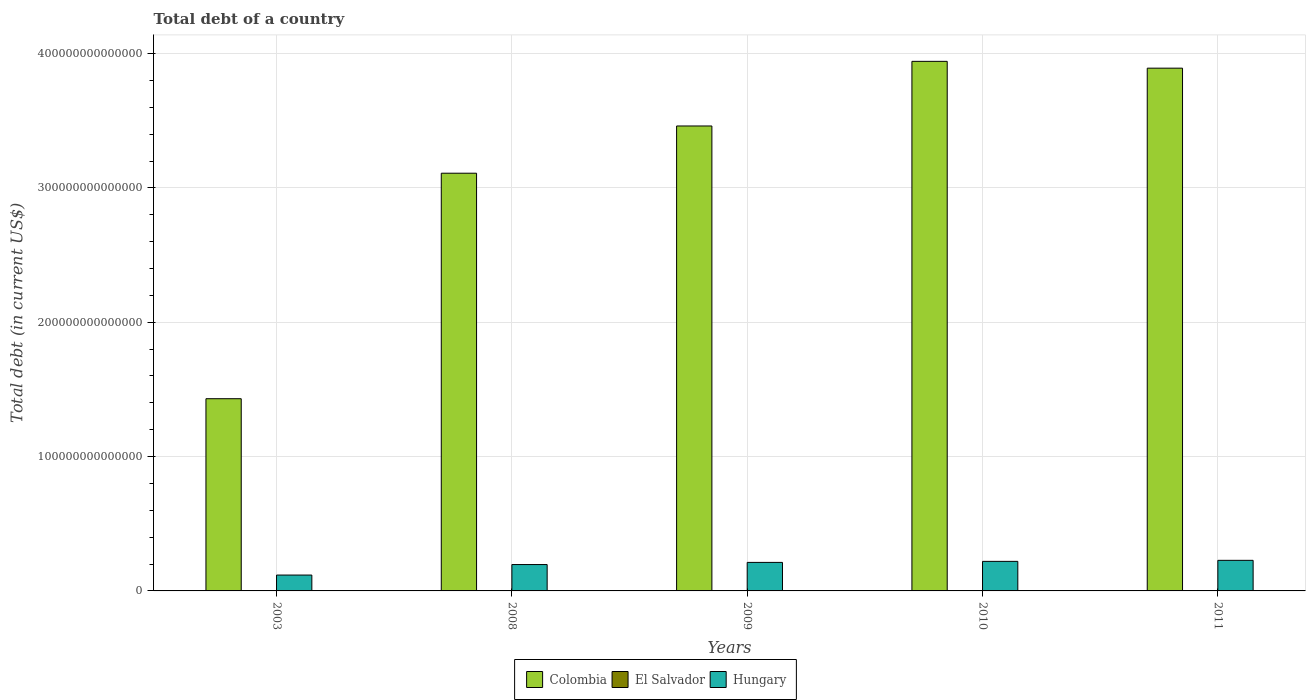How many groups of bars are there?
Keep it short and to the point. 5. Are the number of bars per tick equal to the number of legend labels?
Make the answer very short. Yes. Are the number of bars on each tick of the X-axis equal?
Your answer should be compact. Yes. What is the label of the 4th group of bars from the left?
Provide a succinct answer. 2010. What is the debt in El Salvador in 2011?
Ensure brevity in your answer.  1.11e+1. Across all years, what is the maximum debt in Colombia?
Ensure brevity in your answer.  3.94e+14. Across all years, what is the minimum debt in Colombia?
Give a very brief answer. 1.43e+14. What is the total debt in Hungary in the graph?
Ensure brevity in your answer.  9.74e+13. What is the difference between the debt in El Salvador in 2008 and that in 2010?
Provide a succinct answer. -1.90e+09. What is the difference between the debt in Colombia in 2010 and the debt in Hungary in 2003?
Provide a succinct answer. 3.82e+14. What is the average debt in El Salvador per year?
Your answer should be very brief. 9.66e+09. In the year 2009, what is the difference between the debt in El Salvador and debt in Colombia?
Your response must be concise. -3.46e+14. In how many years, is the debt in El Salvador greater than 140000000000000 US$?
Your response must be concise. 0. What is the ratio of the debt in Colombia in 2009 to that in 2011?
Offer a terse response. 0.89. What is the difference between the highest and the second highest debt in El Salvador?
Provide a short and direct response. 4.61e+08. What is the difference between the highest and the lowest debt in El Salvador?
Offer a terse response. 3.40e+09. What does the 3rd bar from the left in 2003 represents?
Keep it short and to the point. Hungary. What does the 1st bar from the right in 2009 represents?
Provide a short and direct response. Hungary. Is it the case that in every year, the sum of the debt in El Salvador and debt in Colombia is greater than the debt in Hungary?
Provide a short and direct response. Yes. Are all the bars in the graph horizontal?
Your response must be concise. No. How many years are there in the graph?
Your answer should be very brief. 5. What is the difference between two consecutive major ticks on the Y-axis?
Provide a succinct answer. 1.00e+14. Are the values on the major ticks of Y-axis written in scientific E-notation?
Provide a short and direct response. No. Does the graph contain any zero values?
Give a very brief answer. No. Does the graph contain grids?
Keep it short and to the point. Yes. Where does the legend appear in the graph?
Offer a terse response. Bottom center. How many legend labels are there?
Offer a very short reply. 3. What is the title of the graph?
Keep it short and to the point. Total debt of a country. What is the label or title of the Y-axis?
Your answer should be compact. Total debt (in current US$). What is the Total debt (in current US$) of Colombia in 2003?
Ensure brevity in your answer.  1.43e+14. What is the Total debt (in current US$) of El Salvador in 2003?
Offer a terse response. 7.67e+09. What is the Total debt (in current US$) in Hungary in 2003?
Provide a short and direct response. 1.18e+13. What is the Total debt (in current US$) in Colombia in 2008?
Offer a terse response. 3.11e+14. What is the Total debt (in current US$) in El Salvador in 2008?
Offer a terse response. 8.71e+09. What is the Total debt (in current US$) in Hungary in 2008?
Make the answer very short. 1.96e+13. What is the Total debt (in current US$) of Colombia in 2009?
Keep it short and to the point. 3.46e+14. What is the Total debt (in current US$) of El Salvador in 2009?
Offer a terse response. 1.02e+1. What is the Total debt (in current US$) of Hungary in 2009?
Offer a terse response. 2.12e+13. What is the Total debt (in current US$) of Colombia in 2010?
Your answer should be compact. 3.94e+14. What is the Total debt (in current US$) in El Salvador in 2010?
Offer a terse response. 1.06e+1. What is the Total debt (in current US$) in Hungary in 2010?
Your response must be concise. 2.20e+13. What is the Total debt (in current US$) of Colombia in 2011?
Ensure brevity in your answer.  3.89e+14. What is the Total debt (in current US$) in El Salvador in 2011?
Provide a short and direct response. 1.11e+1. What is the Total debt (in current US$) of Hungary in 2011?
Make the answer very short. 2.28e+13. Across all years, what is the maximum Total debt (in current US$) of Colombia?
Your answer should be compact. 3.94e+14. Across all years, what is the maximum Total debt (in current US$) of El Salvador?
Your response must be concise. 1.11e+1. Across all years, what is the maximum Total debt (in current US$) of Hungary?
Keep it short and to the point. 2.28e+13. Across all years, what is the minimum Total debt (in current US$) in Colombia?
Give a very brief answer. 1.43e+14. Across all years, what is the minimum Total debt (in current US$) of El Salvador?
Your answer should be very brief. 7.67e+09. Across all years, what is the minimum Total debt (in current US$) in Hungary?
Your answer should be compact. 1.18e+13. What is the total Total debt (in current US$) in Colombia in the graph?
Your answer should be compact. 1.58e+15. What is the total Total debt (in current US$) in El Salvador in the graph?
Keep it short and to the point. 4.83e+1. What is the total Total debt (in current US$) in Hungary in the graph?
Your answer should be very brief. 9.74e+13. What is the difference between the Total debt (in current US$) in Colombia in 2003 and that in 2008?
Provide a succinct answer. -1.68e+14. What is the difference between the Total debt (in current US$) of El Salvador in 2003 and that in 2008?
Your answer should be compact. -1.04e+09. What is the difference between the Total debt (in current US$) of Hungary in 2003 and that in 2008?
Keep it short and to the point. -7.82e+12. What is the difference between the Total debt (in current US$) in Colombia in 2003 and that in 2009?
Your answer should be compact. -2.03e+14. What is the difference between the Total debt (in current US$) of El Salvador in 2003 and that in 2009?
Provide a short and direct response. -2.57e+09. What is the difference between the Total debt (in current US$) of Hungary in 2003 and that in 2009?
Provide a short and direct response. -9.41e+12. What is the difference between the Total debt (in current US$) of Colombia in 2003 and that in 2010?
Your answer should be very brief. -2.51e+14. What is the difference between the Total debt (in current US$) of El Salvador in 2003 and that in 2010?
Keep it short and to the point. -2.94e+09. What is the difference between the Total debt (in current US$) in Hungary in 2003 and that in 2010?
Your answer should be very brief. -1.02e+13. What is the difference between the Total debt (in current US$) in Colombia in 2003 and that in 2011?
Provide a short and direct response. -2.46e+14. What is the difference between the Total debt (in current US$) of El Salvador in 2003 and that in 2011?
Your answer should be very brief. -3.40e+09. What is the difference between the Total debt (in current US$) in Hungary in 2003 and that in 2011?
Your answer should be compact. -1.10e+13. What is the difference between the Total debt (in current US$) of Colombia in 2008 and that in 2009?
Provide a succinct answer. -3.52e+13. What is the difference between the Total debt (in current US$) in El Salvador in 2008 and that in 2009?
Make the answer very short. -1.52e+09. What is the difference between the Total debt (in current US$) of Hungary in 2008 and that in 2009?
Make the answer very short. -1.60e+12. What is the difference between the Total debt (in current US$) in Colombia in 2008 and that in 2010?
Your answer should be compact. -8.33e+13. What is the difference between the Total debt (in current US$) in El Salvador in 2008 and that in 2010?
Offer a very short reply. -1.90e+09. What is the difference between the Total debt (in current US$) in Hungary in 2008 and that in 2010?
Provide a succinct answer. -2.37e+12. What is the difference between the Total debt (in current US$) in Colombia in 2008 and that in 2011?
Offer a very short reply. -7.82e+13. What is the difference between the Total debt (in current US$) of El Salvador in 2008 and that in 2011?
Offer a terse response. -2.36e+09. What is the difference between the Total debt (in current US$) of Hungary in 2008 and that in 2011?
Give a very brief answer. -3.14e+12. What is the difference between the Total debt (in current US$) in Colombia in 2009 and that in 2010?
Your response must be concise. -4.81e+13. What is the difference between the Total debt (in current US$) of El Salvador in 2009 and that in 2010?
Your answer should be compact. -3.72e+08. What is the difference between the Total debt (in current US$) of Hungary in 2009 and that in 2010?
Keep it short and to the point. -7.75e+11. What is the difference between the Total debt (in current US$) in Colombia in 2009 and that in 2011?
Provide a short and direct response. -4.30e+13. What is the difference between the Total debt (in current US$) of El Salvador in 2009 and that in 2011?
Your answer should be compact. -8.33e+08. What is the difference between the Total debt (in current US$) of Hungary in 2009 and that in 2011?
Give a very brief answer. -1.54e+12. What is the difference between the Total debt (in current US$) in Colombia in 2010 and that in 2011?
Your answer should be very brief. 5.07e+12. What is the difference between the Total debt (in current US$) of El Salvador in 2010 and that in 2011?
Ensure brevity in your answer.  -4.61e+08. What is the difference between the Total debt (in current US$) in Hungary in 2010 and that in 2011?
Give a very brief answer. -7.70e+11. What is the difference between the Total debt (in current US$) in Colombia in 2003 and the Total debt (in current US$) in El Salvador in 2008?
Your answer should be compact. 1.43e+14. What is the difference between the Total debt (in current US$) in Colombia in 2003 and the Total debt (in current US$) in Hungary in 2008?
Provide a short and direct response. 1.23e+14. What is the difference between the Total debt (in current US$) in El Salvador in 2003 and the Total debt (in current US$) in Hungary in 2008?
Give a very brief answer. -1.96e+13. What is the difference between the Total debt (in current US$) of Colombia in 2003 and the Total debt (in current US$) of El Salvador in 2009?
Keep it short and to the point. 1.43e+14. What is the difference between the Total debt (in current US$) of Colombia in 2003 and the Total debt (in current US$) of Hungary in 2009?
Your answer should be compact. 1.22e+14. What is the difference between the Total debt (in current US$) in El Salvador in 2003 and the Total debt (in current US$) in Hungary in 2009?
Ensure brevity in your answer.  -2.12e+13. What is the difference between the Total debt (in current US$) of Colombia in 2003 and the Total debt (in current US$) of El Salvador in 2010?
Give a very brief answer. 1.43e+14. What is the difference between the Total debt (in current US$) in Colombia in 2003 and the Total debt (in current US$) in Hungary in 2010?
Ensure brevity in your answer.  1.21e+14. What is the difference between the Total debt (in current US$) in El Salvador in 2003 and the Total debt (in current US$) in Hungary in 2010?
Keep it short and to the point. -2.20e+13. What is the difference between the Total debt (in current US$) of Colombia in 2003 and the Total debt (in current US$) of El Salvador in 2011?
Provide a succinct answer. 1.43e+14. What is the difference between the Total debt (in current US$) in Colombia in 2003 and the Total debt (in current US$) in Hungary in 2011?
Your answer should be very brief. 1.20e+14. What is the difference between the Total debt (in current US$) in El Salvador in 2003 and the Total debt (in current US$) in Hungary in 2011?
Offer a very short reply. -2.28e+13. What is the difference between the Total debt (in current US$) of Colombia in 2008 and the Total debt (in current US$) of El Salvador in 2009?
Make the answer very short. 3.11e+14. What is the difference between the Total debt (in current US$) of Colombia in 2008 and the Total debt (in current US$) of Hungary in 2009?
Provide a short and direct response. 2.90e+14. What is the difference between the Total debt (in current US$) in El Salvador in 2008 and the Total debt (in current US$) in Hungary in 2009?
Provide a succinct answer. -2.12e+13. What is the difference between the Total debt (in current US$) of Colombia in 2008 and the Total debt (in current US$) of El Salvador in 2010?
Give a very brief answer. 3.11e+14. What is the difference between the Total debt (in current US$) of Colombia in 2008 and the Total debt (in current US$) of Hungary in 2010?
Offer a very short reply. 2.89e+14. What is the difference between the Total debt (in current US$) in El Salvador in 2008 and the Total debt (in current US$) in Hungary in 2010?
Offer a very short reply. -2.20e+13. What is the difference between the Total debt (in current US$) in Colombia in 2008 and the Total debt (in current US$) in El Salvador in 2011?
Your answer should be very brief. 3.11e+14. What is the difference between the Total debt (in current US$) of Colombia in 2008 and the Total debt (in current US$) of Hungary in 2011?
Your answer should be compact. 2.88e+14. What is the difference between the Total debt (in current US$) in El Salvador in 2008 and the Total debt (in current US$) in Hungary in 2011?
Your response must be concise. -2.28e+13. What is the difference between the Total debt (in current US$) of Colombia in 2009 and the Total debt (in current US$) of El Salvador in 2010?
Provide a succinct answer. 3.46e+14. What is the difference between the Total debt (in current US$) in Colombia in 2009 and the Total debt (in current US$) in Hungary in 2010?
Ensure brevity in your answer.  3.24e+14. What is the difference between the Total debt (in current US$) in El Salvador in 2009 and the Total debt (in current US$) in Hungary in 2010?
Provide a succinct answer. -2.20e+13. What is the difference between the Total debt (in current US$) in Colombia in 2009 and the Total debt (in current US$) in El Salvador in 2011?
Your answer should be compact. 3.46e+14. What is the difference between the Total debt (in current US$) of Colombia in 2009 and the Total debt (in current US$) of Hungary in 2011?
Give a very brief answer. 3.23e+14. What is the difference between the Total debt (in current US$) in El Salvador in 2009 and the Total debt (in current US$) in Hungary in 2011?
Ensure brevity in your answer.  -2.28e+13. What is the difference between the Total debt (in current US$) of Colombia in 2010 and the Total debt (in current US$) of El Salvador in 2011?
Keep it short and to the point. 3.94e+14. What is the difference between the Total debt (in current US$) of Colombia in 2010 and the Total debt (in current US$) of Hungary in 2011?
Your response must be concise. 3.71e+14. What is the difference between the Total debt (in current US$) of El Salvador in 2010 and the Total debt (in current US$) of Hungary in 2011?
Ensure brevity in your answer.  -2.28e+13. What is the average Total debt (in current US$) of Colombia per year?
Make the answer very short. 3.17e+14. What is the average Total debt (in current US$) in El Salvador per year?
Keep it short and to the point. 9.66e+09. What is the average Total debt (in current US$) in Hungary per year?
Your answer should be very brief. 1.95e+13. In the year 2003, what is the difference between the Total debt (in current US$) of Colombia and Total debt (in current US$) of El Salvador?
Your answer should be very brief. 1.43e+14. In the year 2003, what is the difference between the Total debt (in current US$) of Colombia and Total debt (in current US$) of Hungary?
Offer a terse response. 1.31e+14. In the year 2003, what is the difference between the Total debt (in current US$) in El Salvador and Total debt (in current US$) in Hungary?
Provide a succinct answer. -1.18e+13. In the year 2008, what is the difference between the Total debt (in current US$) in Colombia and Total debt (in current US$) in El Salvador?
Give a very brief answer. 3.11e+14. In the year 2008, what is the difference between the Total debt (in current US$) of Colombia and Total debt (in current US$) of Hungary?
Ensure brevity in your answer.  2.91e+14. In the year 2008, what is the difference between the Total debt (in current US$) in El Salvador and Total debt (in current US$) in Hungary?
Offer a terse response. -1.96e+13. In the year 2009, what is the difference between the Total debt (in current US$) in Colombia and Total debt (in current US$) in El Salvador?
Your answer should be very brief. 3.46e+14. In the year 2009, what is the difference between the Total debt (in current US$) in Colombia and Total debt (in current US$) in Hungary?
Make the answer very short. 3.25e+14. In the year 2009, what is the difference between the Total debt (in current US$) of El Salvador and Total debt (in current US$) of Hungary?
Make the answer very short. -2.12e+13. In the year 2010, what is the difference between the Total debt (in current US$) of Colombia and Total debt (in current US$) of El Salvador?
Your answer should be very brief. 3.94e+14. In the year 2010, what is the difference between the Total debt (in current US$) in Colombia and Total debt (in current US$) in Hungary?
Offer a terse response. 3.72e+14. In the year 2010, what is the difference between the Total debt (in current US$) of El Salvador and Total debt (in current US$) of Hungary?
Provide a short and direct response. -2.20e+13. In the year 2011, what is the difference between the Total debt (in current US$) in Colombia and Total debt (in current US$) in El Salvador?
Make the answer very short. 3.89e+14. In the year 2011, what is the difference between the Total debt (in current US$) in Colombia and Total debt (in current US$) in Hungary?
Your response must be concise. 3.66e+14. In the year 2011, what is the difference between the Total debt (in current US$) in El Salvador and Total debt (in current US$) in Hungary?
Provide a succinct answer. -2.28e+13. What is the ratio of the Total debt (in current US$) of Colombia in 2003 to that in 2008?
Make the answer very short. 0.46. What is the ratio of the Total debt (in current US$) of El Salvador in 2003 to that in 2008?
Provide a succinct answer. 0.88. What is the ratio of the Total debt (in current US$) in Hungary in 2003 to that in 2008?
Give a very brief answer. 0.6. What is the ratio of the Total debt (in current US$) in Colombia in 2003 to that in 2009?
Your answer should be very brief. 0.41. What is the ratio of the Total debt (in current US$) of El Salvador in 2003 to that in 2009?
Make the answer very short. 0.75. What is the ratio of the Total debt (in current US$) of Hungary in 2003 to that in 2009?
Your answer should be very brief. 0.56. What is the ratio of the Total debt (in current US$) of Colombia in 2003 to that in 2010?
Your answer should be very brief. 0.36. What is the ratio of the Total debt (in current US$) in El Salvador in 2003 to that in 2010?
Make the answer very short. 0.72. What is the ratio of the Total debt (in current US$) of Hungary in 2003 to that in 2010?
Your answer should be very brief. 0.54. What is the ratio of the Total debt (in current US$) of Colombia in 2003 to that in 2011?
Your answer should be very brief. 0.37. What is the ratio of the Total debt (in current US$) in El Salvador in 2003 to that in 2011?
Provide a succinct answer. 0.69. What is the ratio of the Total debt (in current US$) of Hungary in 2003 to that in 2011?
Your response must be concise. 0.52. What is the ratio of the Total debt (in current US$) of Colombia in 2008 to that in 2009?
Make the answer very short. 0.9. What is the ratio of the Total debt (in current US$) in El Salvador in 2008 to that in 2009?
Your answer should be very brief. 0.85. What is the ratio of the Total debt (in current US$) of Hungary in 2008 to that in 2009?
Ensure brevity in your answer.  0.92. What is the ratio of the Total debt (in current US$) in Colombia in 2008 to that in 2010?
Your answer should be compact. 0.79. What is the ratio of the Total debt (in current US$) of El Salvador in 2008 to that in 2010?
Keep it short and to the point. 0.82. What is the ratio of the Total debt (in current US$) in Hungary in 2008 to that in 2010?
Offer a very short reply. 0.89. What is the ratio of the Total debt (in current US$) of Colombia in 2008 to that in 2011?
Provide a succinct answer. 0.8. What is the ratio of the Total debt (in current US$) in El Salvador in 2008 to that in 2011?
Your answer should be very brief. 0.79. What is the ratio of the Total debt (in current US$) of Hungary in 2008 to that in 2011?
Give a very brief answer. 0.86. What is the ratio of the Total debt (in current US$) of Colombia in 2009 to that in 2010?
Provide a short and direct response. 0.88. What is the ratio of the Total debt (in current US$) of El Salvador in 2009 to that in 2010?
Provide a short and direct response. 0.96. What is the ratio of the Total debt (in current US$) of Hungary in 2009 to that in 2010?
Make the answer very short. 0.96. What is the ratio of the Total debt (in current US$) in Colombia in 2009 to that in 2011?
Make the answer very short. 0.89. What is the ratio of the Total debt (in current US$) of El Salvador in 2009 to that in 2011?
Offer a terse response. 0.92. What is the ratio of the Total debt (in current US$) of Hungary in 2009 to that in 2011?
Provide a short and direct response. 0.93. What is the ratio of the Total debt (in current US$) in El Salvador in 2010 to that in 2011?
Make the answer very short. 0.96. What is the ratio of the Total debt (in current US$) of Hungary in 2010 to that in 2011?
Keep it short and to the point. 0.97. What is the difference between the highest and the second highest Total debt (in current US$) of Colombia?
Provide a short and direct response. 5.07e+12. What is the difference between the highest and the second highest Total debt (in current US$) of El Salvador?
Your response must be concise. 4.61e+08. What is the difference between the highest and the second highest Total debt (in current US$) of Hungary?
Offer a terse response. 7.70e+11. What is the difference between the highest and the lowest Total debt (in current US$) of Colombia?
Offer a very short reply. 2.51e+14. What is the difference between the highest and the lowest Total debt (in current US$) of El Salvador?
Ensure brevity in your answer.  3.40e+09. What is the difference between the highest and the lowest Total debt (in current US$) in Hungary?
Give a very brief answer. 1.10e+13. 